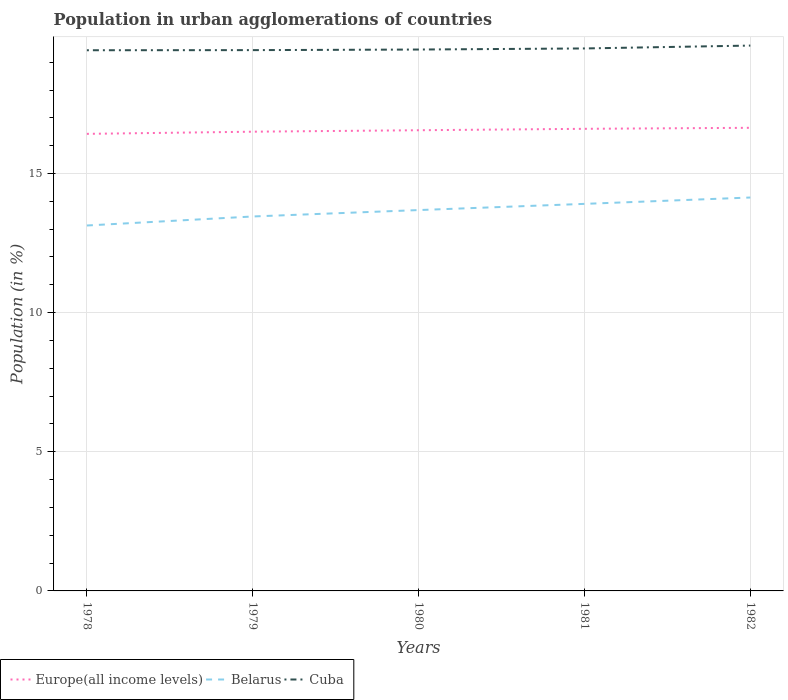How many different coloured lines are there?
Provide a short and direct response. 3. Across all years, what is the maximum percentage of population in urban agglomerations in Cuba?
Provide a succinct answer. 19.43. In which year was the percentage of population in urban agglomerations in Cuba maximum?
Provide a succinct answer. 1978. What is the total percentage of population in urban agglomerations in Belarus in the graph?
Your response must be concise. -0.45. What is the difference between the highest and the second highest percentage of population in urban agglomerations in Europe(all income levels)?
Ensure brevity in your answer.  0.22. What is the difference between the highest and the lowest percentage of population in urban agglomerations in Belarus?
Ensure brevity in your answer.  3. Is the percentage of population in urban agglomerations in Cuba strictly greater than the percentage of population in urban agglomerations in Europe(all income levels) over the years?
Provide a succinct answer. No. How many lines are there?
Make the answer very short. 3. Are the values on the major ticks of Y-axis written in scientific E-notation?
Your response must be concise. No. Does the graph contain any zero values?
Provide a short and direct response. No. What is the title of the graph?
Your answer should be very brief. Population in urban agglomerations of countries. What is the label or title of the X-axis?
Offer a very short reply. Years. What is the Population (in %) in Europe(all income levels) in 1978?
Offer a terse response. 16.42. What is the Population (in %) of Belarus in 1978?
Give a very brief answer. 13.13. What is the Population (in %) in Cuba in 1978?
Keep it short and to the point. 19.43. What is the Population (in %) of Europe(all income levels) in 1979?
Make the answer very short. 16.5. What is the Population (in %) in Belarus in 1979?
Provide a short and direct response. 13.46. What is the Population (in %) of Cuba in 1979?
Your answer should be compact. 19.43. What is the Population (in %) of Europe(all income levels) in 1980?
Offer a terse response. 16.55. What is the Population (in %) in Belarus in 1980?
Make the answer very short. 13.69. What is the Population (in %) of Cuba in 1980?
Your response must be concise. 19.45. What is the Population (in %) in Europe(all income levels) in 1981?
Give a very brief answer. 16.61. What is the Population (in %) in Belarus in 1981?
Your answer should be compact. 13.91. What is the Population (in %) of Cuba in 1981?
Offer a terse response. 19.49. What is the Population (in %) of Europe(all income levels) in 1982?
Offer a very short reply. 16.64. What is the Population (in %) of Belarus in 1982?
Keep it short and to the point. 14.14. What is the Population (in %) of Cuba in 1982?
Your answer should be very brief. 19.6. Across all years, what is the maximum Population (in %) in Europe(all income levels)?
Your answer should be very brief. 16.64. Across all years, what is the maximum Population (in %) of Belarus?
Keep it short and to the point. 14.14. Across all years, what is the maximum Population (in %) in Cuba?
Provide a succinct answer. 19.6. Across all years, what is the minimum Population (in %) in Europe(all income levels)?
Your answer should be compact. 16.42. Across all years, what is the minimum Population (in %) of Belarus?
Offer a very short reply. 13.13. Across all years, what is the minimum Population (in %) in Cuba?
Ensure brevity in your answer.  19.43. What is the total Population (in %) of Europe(all income levels) in the graph?
Your answer should be compact. 82.73. What is the total Population (in %) of Belarus in the graph?
Your answer should be compact. 68.32. What is the total Population (in %) of Cuba in the graph?
Provide a short and direct response. 97.41. What is the difference between the Population (in %) of Europe(all income levels) in 1978 and that in 1979?
Make the answer very short. -0.08. What is the difference between the Population (in %) in Belarus in 1978 and that in 1979?
Make the answer very short. -0.32. What is the difference between the Population (in %) of Cuba in 1978 and that in 1979?
Provide a succinct answer. -0. What is the difference between the Population (in %) of Europe(all income levels) in 1978 and that in 1980?
Provide a short and direct response. -0.13. What is the difference between the Population (in %) in Belarus in 1978 and that in 1980?
Provide a short and direct response. -0.55. What is the difference between the Population (in %) of Cuba in 1978 and that in 1980?
Provide a succinct answer. -0.03. What is the difference between the Population (in %) of Europe(all income levels) in 1978 and that in 1981?
Your response must be concise. -0.18. What is the difference between the Population (in %) of Belarus in 1978 and that in 1981?
Offer a terse response. -0.78. What is the difference between the Population (in %) of Cuba in 1978 and that in 1981?
Your answer should be very brief. -0.06. What is the difference between the Population (in %) of Europe(all income levels) in 1978 and that in 1982?
Make the answer very short. -0.22. What is the difference between the Population (in %) in Belarus in 1978 and that in 1982?
Offer a very short reply. -1.01. What is the difference between the Population (in %) of Cuba in 1978 and that in 1982?
Offer a very short reply. -0.17. What is the difference between the Population (in %) in Europe(all income levels) in 1979 and that in 1980?
Your answer should be compact. -0.05. What is the difference between the Population (in %) in Belarus in 1979 and that in 1980?
Give a very brief answer. -0.23. What is the difference between the Population (in %) of Cuba in 1979 and that in 1980?
Ensure brevity in your answer.  -0.02. What is the difference between the Population (in %) of Europe(all income levels) in 1979 and that in 1981?
Your answer should be very brief. -0.1. What is the difference between the Population (in %) in Belarus in 1979 and that in 1981?
Offer a very short reply. -0.45. What is the difference between the Population (in %) in Cuba in 1979 and that in 1981?
Your answer should be compact. -0.06. What is the difference between the Population (in %) of Europe(all income levels) in 1979 and that in 1982?
Keep it short and to the point. -0.14. What is the difference between the Population (in %) in Belarus in 1979 and that in 1982?
Provide a succinct answer. -0.68. What is the difference between the Population (in %) in Cuba in 1979 and that in 1982?
Make the answer very short. -0.16. What is the difference between the Population (in %) in Europe(all income levels) in 1980 and that in 1981?
Your answer should be very brief. -0.05. What is the difference between the Population (in %) of Belarus in 1980 and that in 1981?
Your answer should be very brief. -0.22. What is the difference between the Population (in %) of Cuba in 1980 and that in 1981?
Your response must be concise. -0.04. What is the difference between the Population (in %) of Europe(all income levels) in 1980 and that in 1982?
Give a very brief answer. -0.09. What is the difference between the Population (in %) in Belarus in 1980 and that in 1982?
Make the answer very short. -0.45. What is the difference between the Population (in %) of Cuba in 1980 and that in 1982?
Provide a succinct answer. -0.14. What is the difference between the Population (in %) of Europe(all income levels) in 1981 and that in 1982?
Provide a succinct answer. -0.04. What is the difference between the Population (in %) of Belarus in 1981 and that in 1982?
Your response must be concise. -0.23. What is the difference between the Population (in %) of Cuba in 1981 and that in 1982?
Offer a very short reply. -0.1. What is the difference between the Population (in %) in Europe(all income levels) in 1978 and the Population (in %) in Belarus in 1979?
Make the answer very short. 2.97. What is the difference between the Population (in %) in Europe(all income levels) in 1978 and the Population (in %) in Cuba in 1979?
Make the answer very short. -3.01. What is the difference between the Population (in %) in Belarus in 1978 and the Population (in %) in Cuba in 1979?
Give a very brief answer. -6.3. What is the difference between the Population (in %) in Europe(all income levels) in 1978 and the Population (in %) in Belarus in 1980?
Give a very brief answer. 2.74. What is the difference between the Population (in %) in Europe(all income levels) in 1978 and the Population (in %) in Cuba in 1980?
Keep it short and to the point. -3.03. What is the difference between the Population (in %) in Belarus in 1978 and the Population (in %) in Cuba in 1980?
Offer a very short reply. -6.32. What is the difference between the Population (in %) of Europe(all income levels) in 1978 and the Population (in %) of Belarus in 1981?
Your answer should be compact. 2.52. What is the difference between the Population (in %) of Europe(all income levels) in 1978 and the Population (in %) of Cuba in 1981?
Offer a very short reply. -3.07. What is the difference between the Population (in %) of Belarus in 1978 and the Population (in %) of Cuba in 1981?
Your answer should be very brief. -6.36. What is the difference between the Population (in %) of Europe(all income levels) in 1978 and the Population (in %) of Belarus in 1982?
Give a very brief answer. 2.29. What is the difference between the Population (in %) of Europe(all income levels) in 1978 and the Population (in %) of Cuba in 1982?
Offer a terse response. -3.17. What is the difference between the Population (in %) of Belarus in 1978 and the Population (in %) of Cuba in 1982?
Keep it short and to the point. -6.47. What is the difference between the Population (in %) of Europe(all income levels) in 1979 and the Population (in %) of Belarus in 1980?
Ensure brevity in your answer.  2.82. What is the difference between the Population (in %) in Europe(all income levels) in 1979 and the Population (in %) in Cuba in 1980?
Your answer should be very brief. -2.95. What is the difference between the Population (in %) of Belarus in 1979 and the Population (in %) of Cuba in 1980?
Provide a succinct answer. -6. What is the difference between the Population (in %) in Europe(all income levels) in 1979 and the Population (in %) in Belarus in 1981?
Your answer should be very brief. 2.59. What is the difference between the Population (in %) of Europe(all income levels) in 1979 and the Population (in %) of Cuba in 1981?
Your answer should be compact. -2.99. What is the difference between the Population (in %) in Belarus in 1979 and the Population (in %) in Cuba in 1981?
Provide a short and direct response. -6.04. What is the difference between the Population (in %) of Europe(all income levels) in 1979 and the Population (in %) of Belarus in 1982?
Your response must be concise. 2.37. What is the difference between the Population (in %) in Europe(all income levels) in 1979 and the Population (in %) in Cuba in 1982?
Make the answer very short. -3.09. What is the difference between the Population (in %) of Belarus in 1979 and the Population (in %) of Cuba in 1982?
Provide a succinct answer. -6.14. What is the difference between the Population (in %) in Europe(all income levels) in 1980 and the Population (in %) in Belarus in 1981?
Your response must be concise. 2.65. What is the difference between the Population (in %) of Europe(all income levels) in 1980 and the Population (in %) of Cuba in 1981?
Your answer should be compact. -2.94. What is the difference between the Population (in %) of Belarus in 1980 and the Population (in %) of Cuba in 1981?
Ensure brevity in your answer.  -5.81. What is the difference between the Population (in %) in Europe(all income levels) in 1980 and the Population (in %) in Belarus in 1982?
Provide a succinct answer. 2.42. What is the difference between the Population (in %) of Europe(all income levels) in 1980 and the Population (in %) of Cuba in 1982?
Your answer should be compact. -3.04. What is the difference between the Population (in %) of Belarus in 1980 and the Population (in %) of Cuba in 1982?
Your answer should be very brief. -5.91. What is the difference between the Population (in %) in Europe(all income levels) in 1981 and the Population (in %) in Belarus in 1982?
Offer a very short reply. 2.47. What is the difference between the Population (in %) of Europe(all income levels) in 1981 and the Population (in %) of Cuba in 1982?
Provide a short and direct response. -2.99. What is the difference between the Population (in %) in Belarus in 1981 and the Population (in %) in Cuba in 1982?
Provide a succinct answer. -5.69. What is the average Population (in %) in Europe(all income levels) per year?
Offer a very short reply. 16.55. What is the average Population (in %) in Belarus per year?
Your answer should be very brief. 13.66. What is the average Population (in %) in Cuba per year?
Your answer should be compact. 19.48. In the year 1978, what is the difference between the Population (in %) in Europe(all income levels) and Population (in %) in Belarus?
Keep it short and to the point. 3.29. In the year 1978, what is the difference between the Population (in %) of Europe(all income levels) and Population (in %) of Cuba?
Your answer should be very brief. -3. In the year 1978, what is the difference between the Population (in %) in Belarus and Population (in %) in Cuba?
Provide a succinct answer. -6.3. In the year 1979, what is the difference between the Population (in %) in Europe(all income levels) and Population (in %) in Belarus?
Keep it short and to the point. 3.05. In the year 1979, what is the difference between the Population (in %) in Europe(all income levels) and Population (in %) in Cuba?
Offer a very short reply. -2.93. In the year 1979, what is the difference between the Population (in %) of Belarus and Population (in %) of Cuba?
Your answer should be very brief. -5.98. In the year 1980, what is the difference between the Population (in %) in Europe(all income levels) and Population (in %) in Belarus?
Give a very brief answer. 2.87. In the year 1980, what is the difference between the Population (in %) of Europe(all income levels) and Population (in %) of Cuba?
Make the answer very short. -2.9. In the year 1980, what is the difference between the Population (in %) in Belarus and Population (in %) in Cuba?
Your answer should be compact. -5.77. In the year 1981, what is the difference between the Population (in %) in Europe(all income levels) and Population (in %) in Belarus?
Make the answer very short. 2.7. In the year 1981, what is the difference between the Population (in %) in Europe(all income levels) and Population (in %) in Cuba?
Ensure brevity in your answer.  -2.89. In the year 1981, what is the difference between the Population (in %) of Belarus and Population (in %) of Cuba?
Ensure brevity in your answer.  -5.59. In the year 1982, what is the difference between the Population (in %) in Europe(all income levels) and Population (in %) in Belarus?
Your answer should be very brief. 2.5. In the year 1982, what is the difference between the Population (in %) of Europe(all income levels) and Population (in %) of Cuba?
Your answer should be very brief. -2.96. In the year 1982, what is the difference between the Population (in %) of Belarus and Population (in %) of Cuba?
Keep it short and to the point. -5.46. What is the ratio of the Population (in %) of Belarus in 1978 to that in 1979?
Offer a terse response. 0.98. What is the ratio of the Population (in %) in Cuba in 1978 to that in 1979?
Give a very brief answer. 1. What is the ratio of the Population (in %) in Belarus in 1978 to that in 1980?
Your response must be concise. 0.96. What is the ratio of the Population (in %) in Cuba in 1978 to that in 1980?
Keep it short and to the point. 1. What is the ratio of the Population (in %) in Belarus in 1978 to that in 1981?
Provide a short and direct response. 0.94. What is the ratio of the Population (in %) in Europe(all income levels) in 1978 to that in 1982?
Your response must be concise. 0.99. What is the ratio of the Population (in %) of Belarus in 1978 to that in 1982?
Offer a terse response. 0.93. What is the ratio of the Population (in %) in Europe(all income levels) in 1979 to that in 1980?
Give a very brief answer. 1. What is the ratio of the Population (in %) in Belarus in 1979 to that in 1980?
Provide a succinct answer. 0.98. What is the ratio of the Population (in %) of Belarus in 1979 to that in 1981?
Provide a short and direct response. 0.97. What is the ratio of the Population (in %) in Cuba in 1979 to that in 1981?
Your answer should be compact. 1. What is the ratio of the Population (in %) in Belarus in 1979 to that in 1982?
Ensure brevity in your answer.  0.95. What is the ratio of the Population (in %) of Cuba in 1979 to that in 1982?
Offer a terse response. 0.99. What is the ratio of the Population (in %) in Europe(all income levels) in 1980 to that in 1981?
Give a very brief answer. 1. What is the ratio of the Population (in %) of Belarus in 1980 to that in 1981?
Your answer should be very brief. 0.98. What is the ratio of the Population (in %) of Cuba in 1980 to that in 1981?
Offer a very short reply. 1. What is the ratio of the Population (in %) of Europe(all income levels) in 1980 to that in 1982?
Give a very brief answer. 0.99. What is the ratio of the Population (in %) of Belarus in 1980 to that in 1982?
Your response must be concise. 0.97. What is the ratio of the Population (in %) in Belarus in 1981 to that in 1982?
Your answer should be compact. 0.98. What is the ratio of the Population (in %) in Cuba in 1981 to that in 1982?
Your answer should be very brief. 0.99. What is the difference between the highest and the second highest Population (in %) of Europe(all income levels)?
Provide a short and direct response. 0.04. What is the difference between the highest and the second highest Population (in %) in Belarus?
Make the answer very short. 0.23. What is the difference between the highest and the second highest Population (in %) in Cuba?
Your response must be concise. 0.1. What is the difference between the highest and the lowest Population (in %) in Europe(all income levels)?
Your answer should be very brief. 0.22. What is the difference between the highest and the lowest Population (in %) in Cuba?
Make the answer very short. 0.17. 